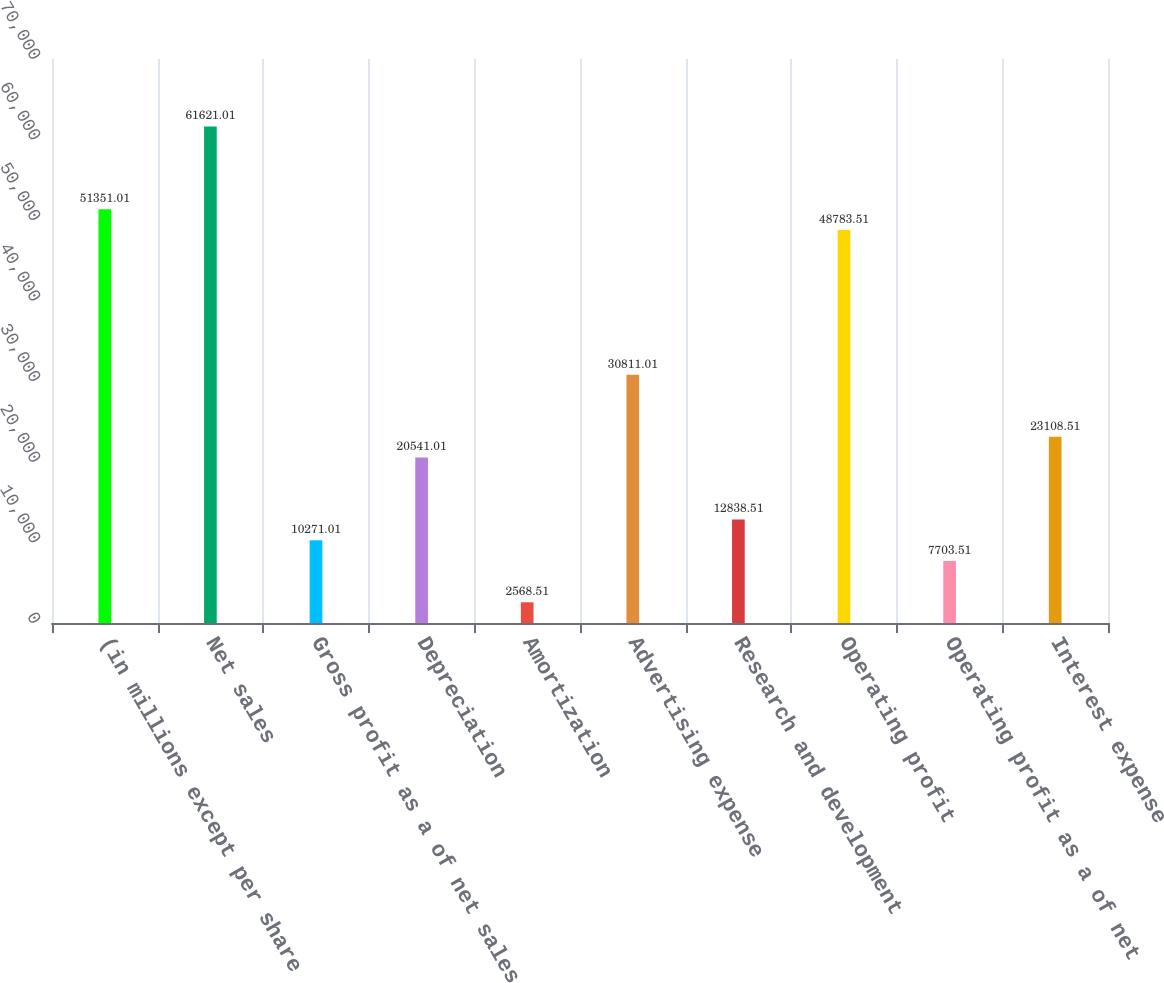Convert chart to OTSL. <chart><loc_0><loc_0><loc_500><loc_500><bar_chart><fcel>(in millions except per share<fcel>Net sales<fcel>Gross profit as a of net sales<fcel>Depreciation<fcel>Amortization<fcel>Advertising expense<fcel>Research and development<fcel>Operating profit<fcel>Operating profit as a of net<fcel>Interest expense<nl><fcel>51351<fcel>61621<fcel>10271<fcel>20541<fcel>2568.51<fcel>30811<fcel>12838.5<fcel>48783.5<fcel>7703.51<fcel>23108.5<nl></chart> 